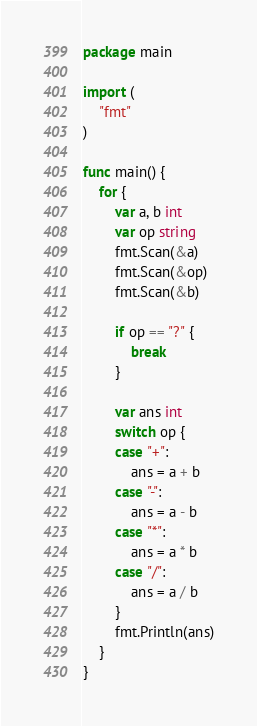<code> <loc_0><loc_0><loc_500><loc_500><_Go_>package main

import (
	"fmt"
)

func main() {
	for {
		var a, b int
		var op string
		fmt.Scan(&a)
		fmt.Scan(&op)
		fmt.Scan(&b)

		if op == "?" {
			break
		}

		var ans int
		switch op {
		case "+":
			ans = a + b
		case "-":
			ans = a - b
		case "*":
			ans = a * b
		case "/":
			ans = a / b
		}
		fmt.Println(ans)
	}
}

</code> 